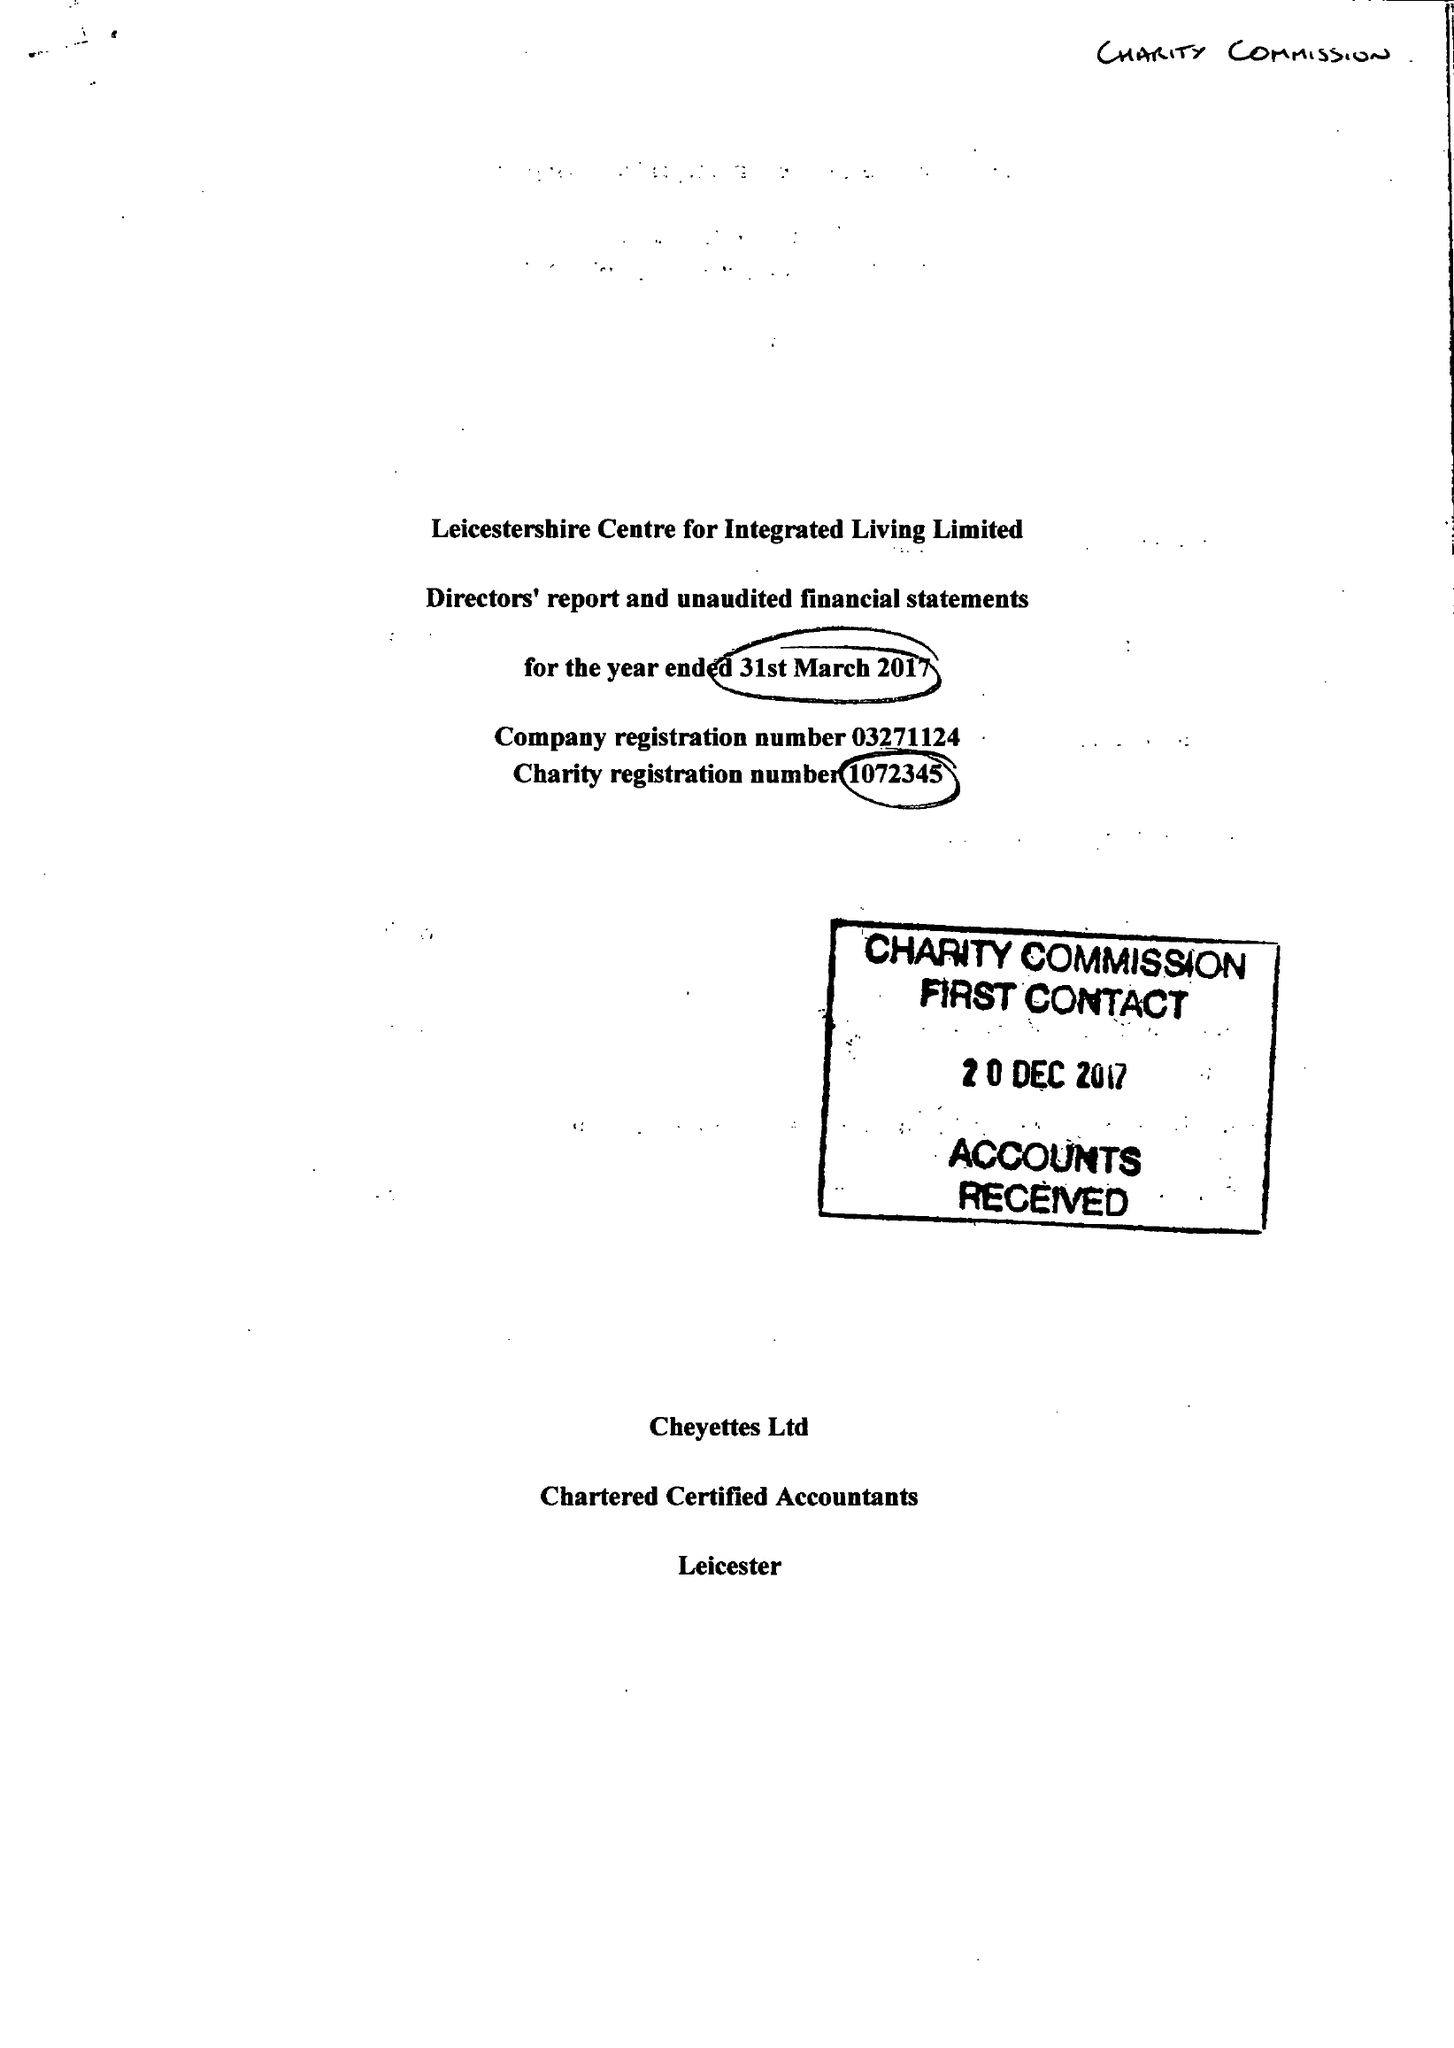What is the value for the report_date?
Answer the question using a single word or phrase. 2017-03-31 